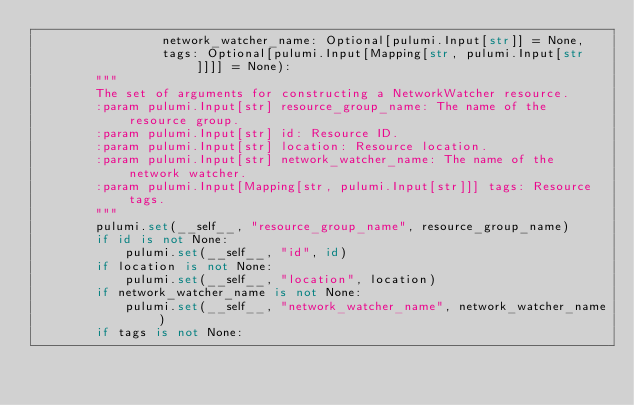<code> <loc_0><loc_0><loc_500><loc_500><_Python_>                 network_watcher_name: Optional[pulumi.Input[str]] = None,
                 tags: Optional[pulumi.Input[Mapping[str, pulumi.Input[str]]]] = None):
        """
        The set of arguments for constructing a NetworkWatcher resource.
        :param pulumi.Input[str] resource_group_name: The name of the resource group.
        :param pulumi.Input[str] id: Resource ID.
        :param pulumi.Input[str] location: Resource location.
        :param pulumi.Input[str] network_watcher_name: The name of the network watcher.
        :param pulumi.Input[Mapping[str, pulumi.Input[str]]] tags: Resource tags.
        """
        pulumi.set(__self__, "resource_group_name", resource_group_name)
        if id is not None:
            pulumi.set(__self__, "id", id)
        if location is not None:
            pulumi.set(__self__, "location", location)
        if network_watcher_name is not None:
            pulumi.set(__self__, "network_watcher_name", network_watcher_name)
        if tags is not None:</code> 